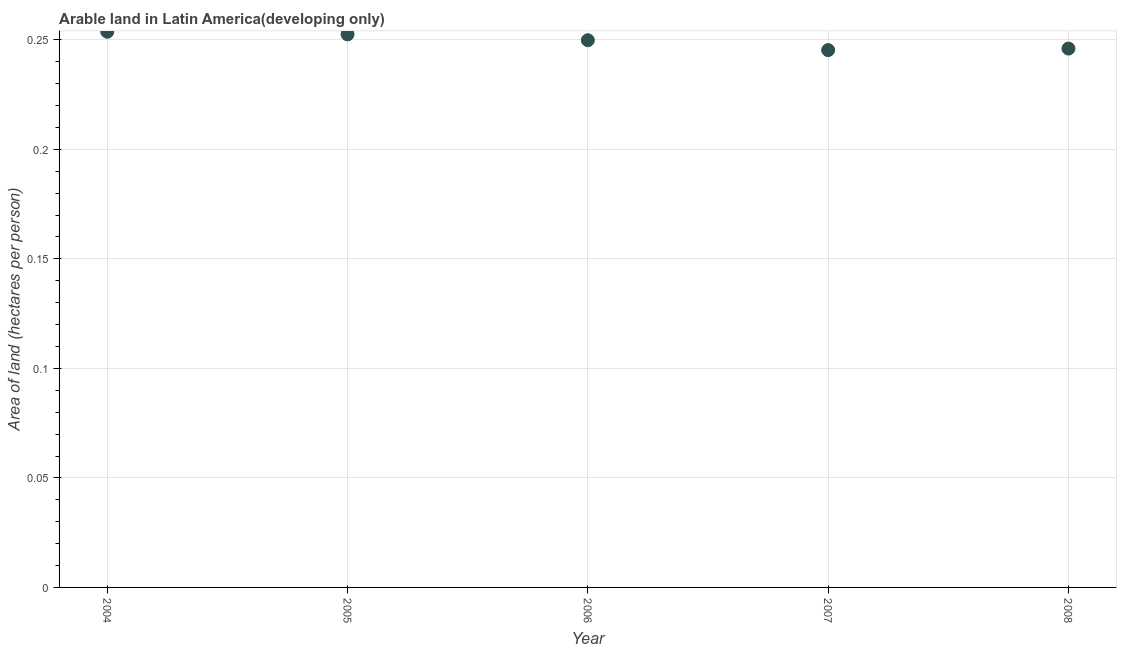What is the area of arable land in 2005?
Your answer should be compact. 0.25. Across all years, what is the maximum area of arable land?
Your answer should be compact. 0.25. Across all years, what is the minimum area of arable land?
Make the answer very short. 0.25. In which year was the area of arable land minimum?
Offer a terse response. 2007. What is the sum of the area of arable land?
Offer a very short reply. 1.25. What is the difference between the area of arable land in 2004 and 2007?
Your response must be concise. 0.01. What is the average area of arable land per year?
Your answer should be very brief. 0.25. What is the median area of arable land?
Make the answer very short. 0.25. What is the ratio of the area of arable land in 2004 to that in 2007?
Give a very brief answer. 1.03. What is the difference between the highest and the second highest area of arable land?
Provide a short and direct response. 0. Is the sum of the area of arable land in 2004 and 2005 greater than the maximum area of arable land across all years?
Ensure brevity in your answer.  Yes. What is the difference between the highest and the lowest area of arable land?
Keep it short and to the point. 0.01. In how many years, is the area of arable land greater than the average area of arable land taken over all years?
Provide a succinct answer. 3. How many dotlines are there?
Your answer should be very brief. 1. What is the title of the graph?
Offer a very short reply. Arable land in Latin America(developing only). What is the label or title of the Y-axis?
Keep it short and to the point. Area of land (hectares per person). What is the Area of land (hectares per person) in 2004?
Your response must be concise. 0.25. What is the Area of land (hectares per person) in 2005?
Ensure brevity in your answer.  0.25. What is the Area of land (hectares per person) in 2006?
Give a very brief answer. 0.25. What is the Area of land (hectares per person) in 2007?
Provide a succinct answer. 0.25. What is the Area of land (hectares per person) in 2008?
Provide a short and direct response. 0.25. What is the difference between the Area of land (hectares per person) in 2004 and 2005?
Ensure brevity in your answer.  0. What is the difference between the Area of land (hectares per person) in 2004 and 2006?
Provide a succinct answer. 0. What is the difference between the Area of land (hectares per person) in 2004 and 2007?
Provide a short and direct response. 0.01. What is the difference between the Area of land (hectares per person) in 2004 and 2008?
Provide a short and direct response. 0.01. What is the difference between the Area of land (hectares per person) in 2005 and 2006?
Give a very brief answer. 0. What is the difference between the Area of land (hectares per person) in 2005 and 2007?
Keep it short and to the point. 0.01. What is the difference between the Area of land (hectares per person) in 2005 and 2008?
Your response must be concise. 0.01. What is the difference between the Area of land (hectares per person) in 2006 and 2007?
Your answer should be very brief. 0. What is the difference between the Area of land (hectares per person) in 2006 and 2008?
Your answer should be very brief. 0. What is the difference between the Area of land (hectares per person) in 2007 and 2008?
Provide a succinct answer. -0. What is the ratio of the Area of land (hectares per person) in 2004 to that in 2007?
Offer a terse response. 1.03. What is the ratio of the Area of land (hectares per person) in 2004 to that in 2008?
Make the answer very short. 1.03. What is the ratio of the Area of land (hectares per person) in 2005 to that in 2007?
Keep it short and to the point. 1.03. What is the ratio of the Area of land (hectares per person) in 2005 to that in 2008?
Provide a short and direct response. 1.03. What is the ratio of the Area of land (hectares per person) in 2006 to that in 2007?
Offer a very short reply. 1.02. What is the ratio of the Area of land (hectares per person) in 2006 to that in 2008?
Provide a short and direct response. 1.01. What is the ratio of the Area of land (hectares per person) in 2007 to that in 2008?
Your answer should be compact. 1. 